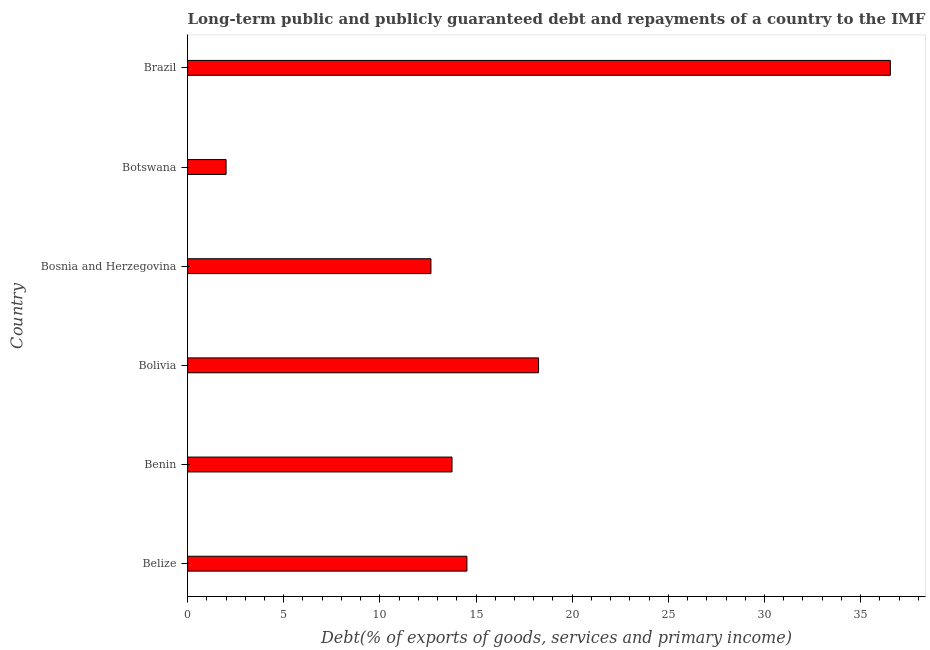What is the title of the graph?
Provide a succinct answer. Long-term public and publicly guaranteed debt and repayments of a country to the IMF in 2000. What is the label or title of the X-axis?
Ensure brevity in your answer.  Debt(% of exports of goods, services and primary income). What is the debt service in Brazil?
Offer a very short reply. 36.54. Across all countries, what is the maximum debt service?
Your answer should be very brief. 36.54. Across all countries, what is the minimum debt service?
Give a very brief answer. 2. In which country was the debt service maximum?
Offer a very short reply. Brazil. In which country was the debt service minimum?
Give a very brief answer. Botswana. What is the sum of the debt service?
Give a very brief answer. 97.73. What is the difference between the debt service in Bosnia and Herzegovina and Brazil?
Make the answer very short. -23.89. What is the average debt service per country?
Give a very brief answer. 16.29. What is the median debt service?
Give a very brief answer. 14.14. In how many countries, is the debt service greater than 12 %?
Your answer should be very brief. 5. What is the ratio of the debt service in Benin to that in Brazil?
Offer a terse response. 0.38. Is the debt service in Benin less than that in Bosnia and Herzegovina?
Offer a terse response. No. Is the difference between the debt service in Belize and Brazil greater than the difference between any two countries?
Provide a succinct answer. No. What is the difference between the highest and the second highest debt service?
Your answer should be very brief. 18.29. What is the difference between the highest and the lowest debt service?
Give a very brief answer. 34.54. How many countries are there in the graph?
Provide a succinct answer. 6. What is the difference between two consecutive major ticks on the X-axis?
Your answer should be compact. 5. Are the values on the major ticks of X-axis written in scientific E-notation?
Offer a terse response. No. What is the Debt(% of exports of goods, services and primary income) in Belize?
Offer a terse response. 14.52. What is the Debt(% of exports of goods, services and primary income) in Benin?
Your answer should be compact. 13.75. What is the Debt(% of exports of goods, services and primary income) in Bolivia?
Keep it short and to the point. 18.25. What is the Debt(% of exports of goods, services and primary income) in Bosnia and Herzegovina?
Your response must be concise. 12.65. What is the Debt(% of exports of goods, services and primary income) in Botswana?
Provide a short and direct response. 2. What is the Debt(% of exports of goods, services and primary income) of Brazil?
Your answer should be compact. 36.54. What is the difference between the Debt(% of exports of goods, services and primary income) in Belize and Benin?
Make the answer very short. 0.77. What is the difference between the Debt(% of exports of goods, services and primary income) in Belize and Bolivia?
Your answer should be very brief. -3.73. What is the difference between the Debt(% of exports of goods, services and primary income) in Belize and Bosnia and Herzegovina?
Your answer should be very brief. 1.87. What is the difference between the Debt(% of exports of goods, services and primary income) in Belize and Botswana?
Your answer should be compact. 12.52. What is the difference between the Debt(% of exports of goods, services and primary income) in Belize and Brazil?
Offer a very short reply. -22.02. What is the difference between the Debt(% of exports of goods, services and primary income) in Benin and Bolivia?
Offer a terse response. -4.5. What is the difference between the Debt(% of exports of goods, services and primary income) in Benin and Bosnia and Herzegovina?
Give a very brief answer. 1.1. What is the difference between the Debt(% of exports of goods, services and primary income) in Benin and Botswana?
Make the answer very short. 11.75. What is the difference between the Debt(% of exports of goods, services and primary income) in Benin and Brazil?
Keep it short and to the point. -22.79. What is the difference between the Debt(% of exports of goods, services and primary income) in Bolivia and Bosnia and Herzegovina?
Your answer should be very brief. 5.6. What is the difference between the Debt(% of exports of goods, services and primary income) in Bolivia and Botswana?
Provide a short and direct response. 16.25. What is the difference between the Debt(% of exports of goods, services and primary income) in Bolivia and Brazil?
Ensure brevity in your answer.  -18.29. What is the difference between the Debt(% of exports of goods, services and primary income) in Bosnia and Herzegovina and Botswana?
Offer a terse response. 10.65. What is the difference between the Debt(% of exports of goods, services and primary income) in Bosnia and Herzegovina and Brazil?
Make the answer very short. -23.89. What is the difference between the Debt(% of exports of goods, services and primary income) in Botswana and Brazil?
Make the answer very short. -34.54. What is the ratio of the Debt(% of exports of goods, services and primary income) in Belize to that in Benin?
Offer a very short reply. 1.06. What is the ratio of the Debt(% of exports of goods, services and primary income) in Belize to that in Bolivia?
Offer a terse response. 0.8. What is the ratio of the Debt(% of exports of goods, services and primary income) in Belize to that in Bosnia and Herzegovina?
Provide a short and direct response. 1.15. What is the ratio of the Debt(% of exports of goods, services and primary income) in Belize to that in Botswana?
Your response must be concise. 7.26. What is the ratio of the Debt(% of exports of goods, services and primary income) in Belize to that in Brazil?
Your answer should be compact. 0.4. What is the ratio of the Debt(% of exports of goods, services and primary income) in Benin to that in Bolivia?
Your answer should be compact. 0.75. What is the ratio of the Debt(% of exports of goods, services and primary income) in Benin to that in Bosnia and Herzegovina?
Provide a succinct answer. 1.09. What is the ratio of the Debt(% of exports of goods, services and primary income) in Benin to that in Botswana?
Make the answer very short. 6.87. What is the ratio of the Debt(% of exports of goods, services and primary income) in Benin to that in Brazil?
Your response must be concise. 0.38. What is the ratio of the Debt(% of exports of goods, services and primary income) in Bolivia to that in Bosnia and Herzegovina?
Ensure brevity in your answer.  1.44. What is the ratio of the Debt(% of exports of goods, services and primary income) in Bolivia to that in Botswana?
Your answer should be compact. 9.12. What is the ratio of the Debt(% of exports of goods, services and primary income) in Bolivia to that in Brazil?
Keep it short and to the point. 0.5. What is the ratio of the Debt(% of exports of goods, services and primary income) in Bosnia and Herzegovina to that in Botswana?
Provide a short and direct response. 6.32. What is the ratio of the Debt(% of exports of goods, services and primary income) in Bosnia and Herzegovina to that in Brazil?
Give a very brief answer. 0.35. What is the ratio of the Debt(% of exports of goods, services and primary income) in Botswana to that in Brazil?
Ensure brevity in your answer.  0.06. 